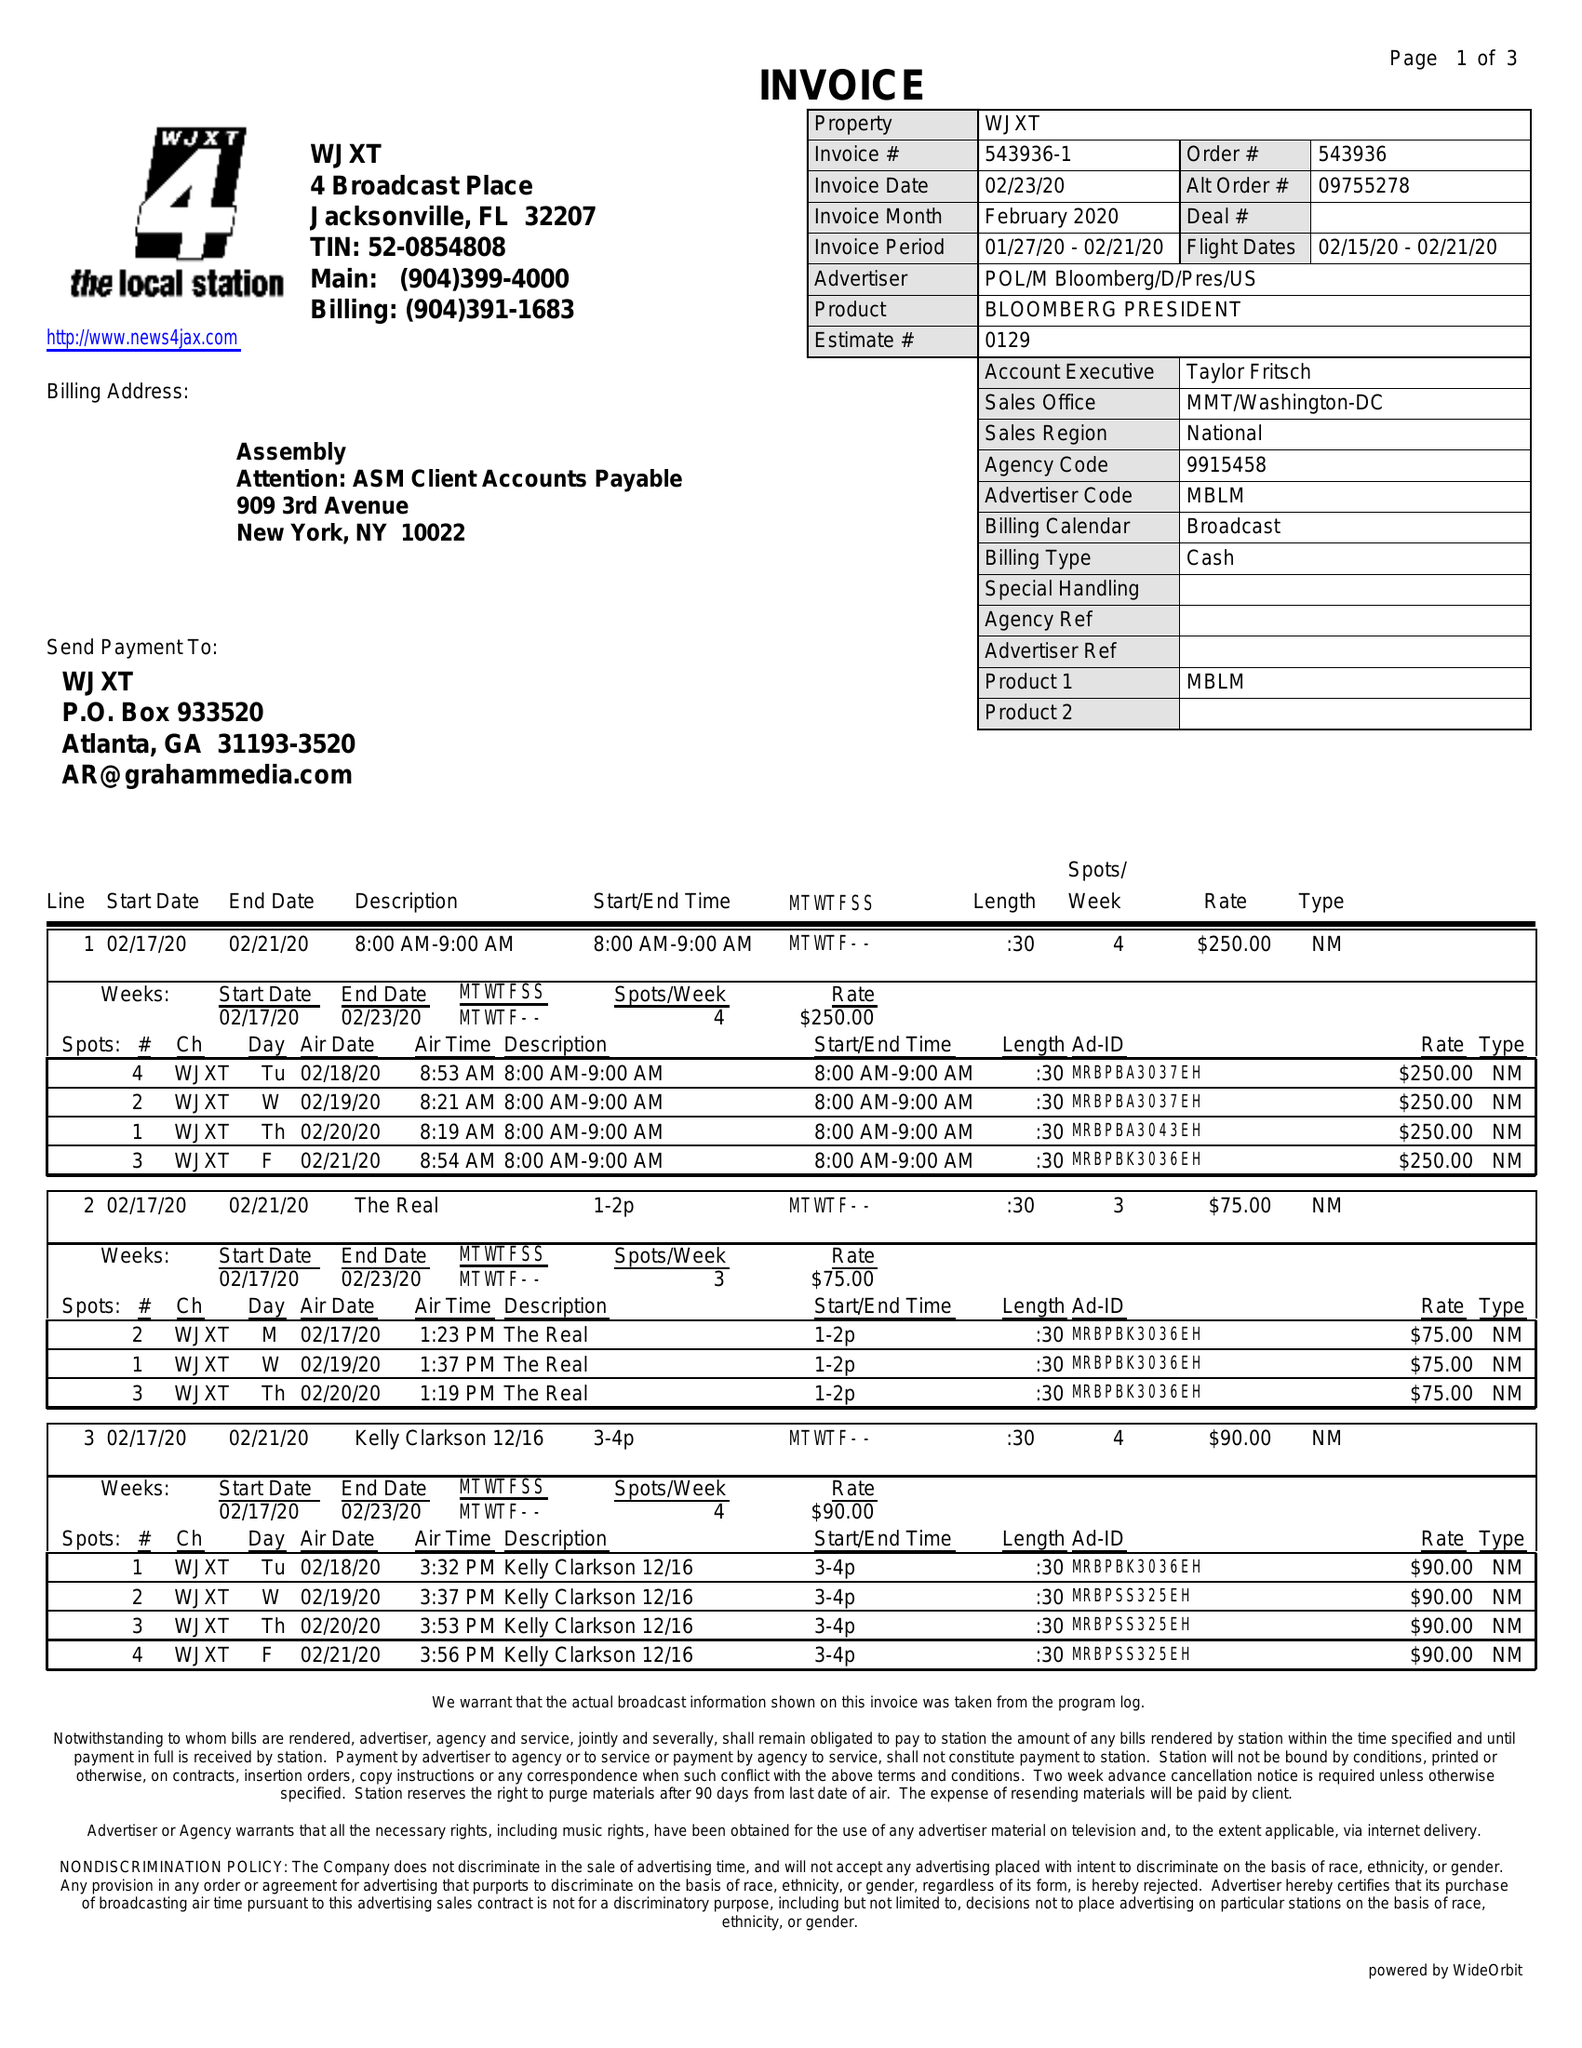What is the value for the flight_from?
Answer the question using a single word or phrase. 02/15/20 